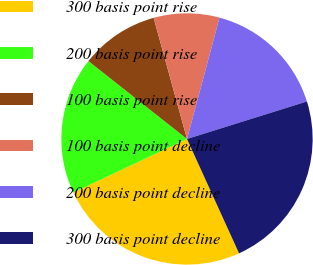Convert chart. <chart><loc_0><loc_0><loc_500><loc_500><pie_chart><fcel>300 basis point rise<fcel>200 basis point rise<fcel>100 basis point rise<fcel>100 basis point decline<fcel>200 basis point decline<fcel>300 basis point decline<nl><fcel>24.79%<fcel>17.65%<fcel>10.08%<fcel>8.44%<fcel>16.01%<fcel>23.03%<nl></chart> 